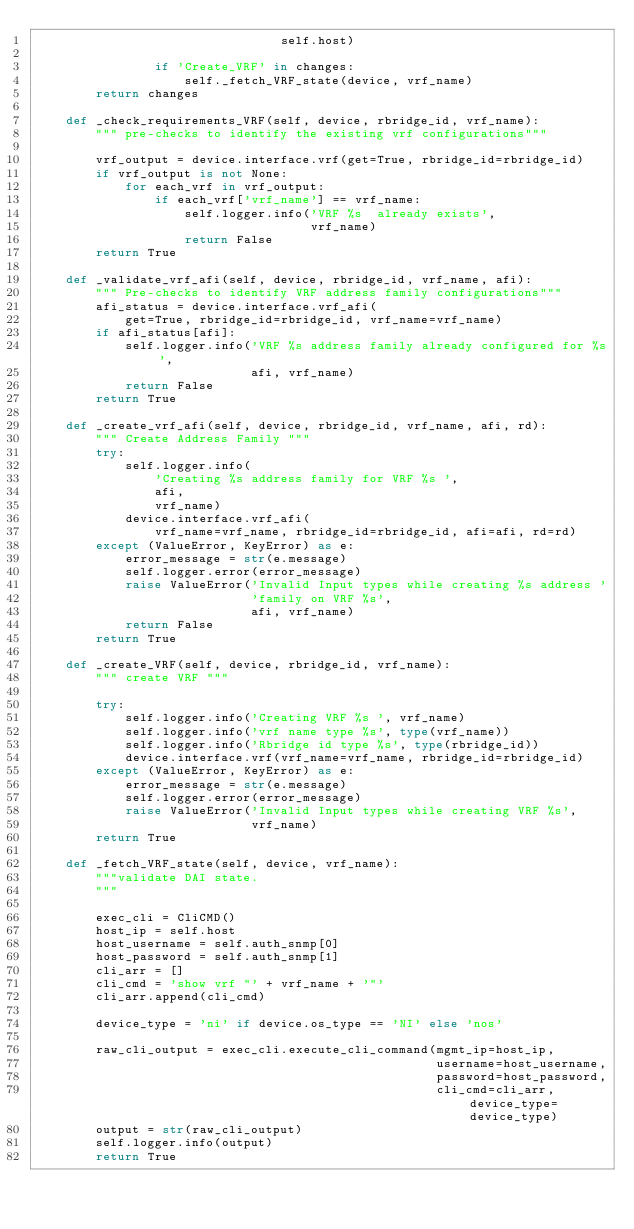Convert code to text. <code><loc_0><loc_0><loc_500><loc_500><_Python_>                                 self.host)

                if 'Create_VRF' in changes:
                    self._fetch_VRF_state(device, vrf_name)
        return changes

    def _check_requirements_VRF(self, device, rbridge_id, vrf_name):
        """ pre-checks to identify the existing vrf configurations"""

        vrf_output = device.interface.vrf(get=True, rbridge_id=rbridge_id)
        if vrf_output is not None:
            for each_vrf in vrf_output:
                if each_vrf['vrf_name'] == vrf_name:
                    self.logger.info('VRF %s  already exists',
                                     vrf_name)
                    return False
        return True

    def _validate_vrf_afi(self, device, rbridge_id, vrf_name, afi):
        """ Pre-checks to identify VRF address family configurations"""
        afi_status = device.interface.vrf_afi(
            get=True, rbridge_id=rbridge_id, vrf_name=vrf_name)
        if afi_status[afi]:
            self.logger.info('VRF %s address family already configured for %s',
                             afi, vrf_name)
            return False
        return True

    def _create_vrf_afi(self, device, rbridge_id, vrf_name, afi, rd):
        """ Create Address Family """
        try:
            self.logger.info(
                'Creating %s address family for VRF %s ',
                afi,
                vrf_name)
            device.interface.vrf_afi(
                vrf_name=vrf_name, rbridge_id=rbridge_id, afi=afi, rd=rd)
        except (ValueError, KeyError) as e:
            error_message = str(e.message)
            self.logger.error(error_message)
            raise ValueError('Invalid Input types while creating %s address '
                             'family on VRF %s',
                             afi, vrf_name)
            return False
        return True

    def _create_VRF(self, device, rbridge_id, vrf_name):
        """ create VRF """

        try:
            self.logger.info('Creating VRF %s ', vrf_name)
            self.logger.info('vrf name type %s', type(vrf_name))
            self.logger.info('Rbridge id type %s', type(rbridge_id))
            device.interface.vrf(vrf_name=vrf_name, rbridge_id=rbridge_id)
        except (ValueError, KeyError) as e:
            error_message = str(e.message)
            self.logger.error(error_message)
            raise ValueError('Invalid Input types while creating VRF %s',
                             vrf_name)
        return True

    def _fetch_VRF_state(self, device, vrf_name):
        """validate DAI state.
        """

        exec_cli = CliCMD()
        host_ip = self.host
        host_username = self.auth_snmp[0]
        host_password = self.auth_snmp[1]
        cli_arr = []
        cli_cmd = 'show vrf "' + vrf_name + '"'
        cli_arr.append(cli_cmd)

        device_type = 'ni' if device.os_type == 'NI' else 'nos'

        raw_cli_output = exec_cli.execute_cli_command(mgmt_ip=host_ip,
                                                      username=host_username,
                                                      password=host_password,
                                                      cli_cmd=cli_arr, device_type=device_type)
        output = str(raw_cli_output)
        self.logger.info(output)
        return True
</code> 